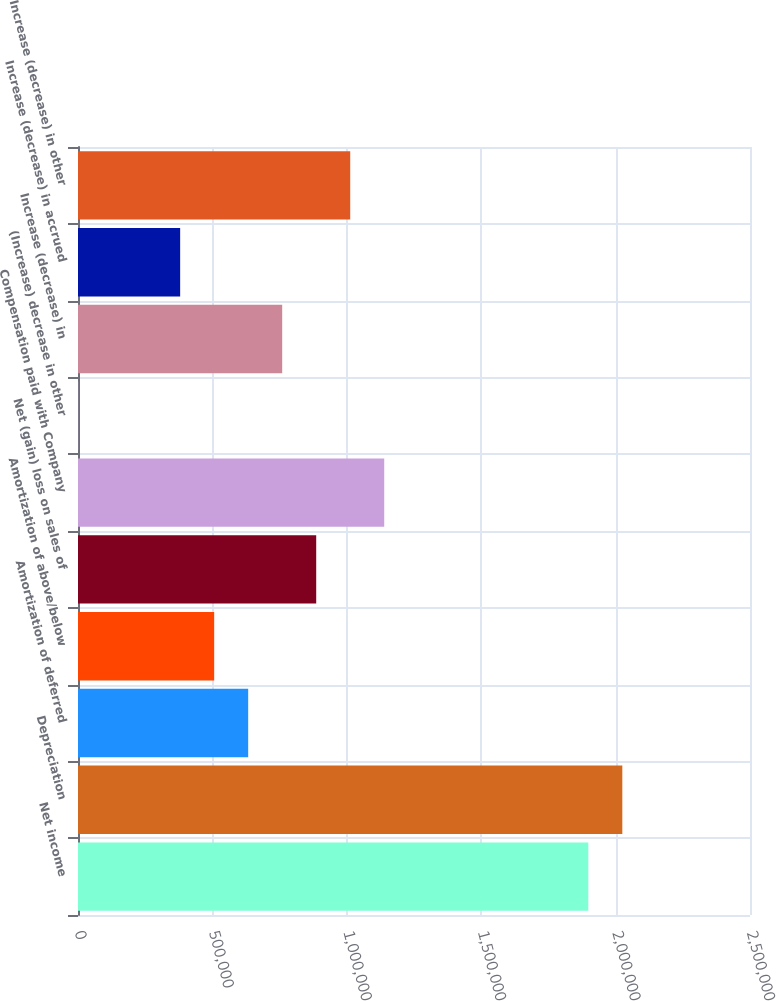Convert chart. <chart><loc_0><loc_0><loc_500><loc_500><bar_chart><fcel>Net income<fcel>Depreciation<fcel>Amortization of deferred<fcel>Amortization of above/below<fcel>Net (gain) loss on sales of<fcel>Compensation paid with Company<fcel>(Increase) decrease in other<fcel>Increase (decrease) in<fcel>Increase (decrease) in accrued<fcel>Increase (decrease) in other<nl><fcel>1.89846e+06<fcel>2.02499e+06<fcel>633118<fcel>506585<fcel>886186<fcel>1.13925e+06<fcel>449<fcel>759652<fcel>380051<fcel>1.01272e+06<nl></chart> 